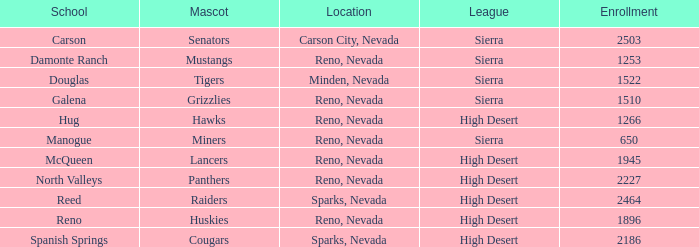In what city and state does the lancers mascot reside? Reno, Nevada. 